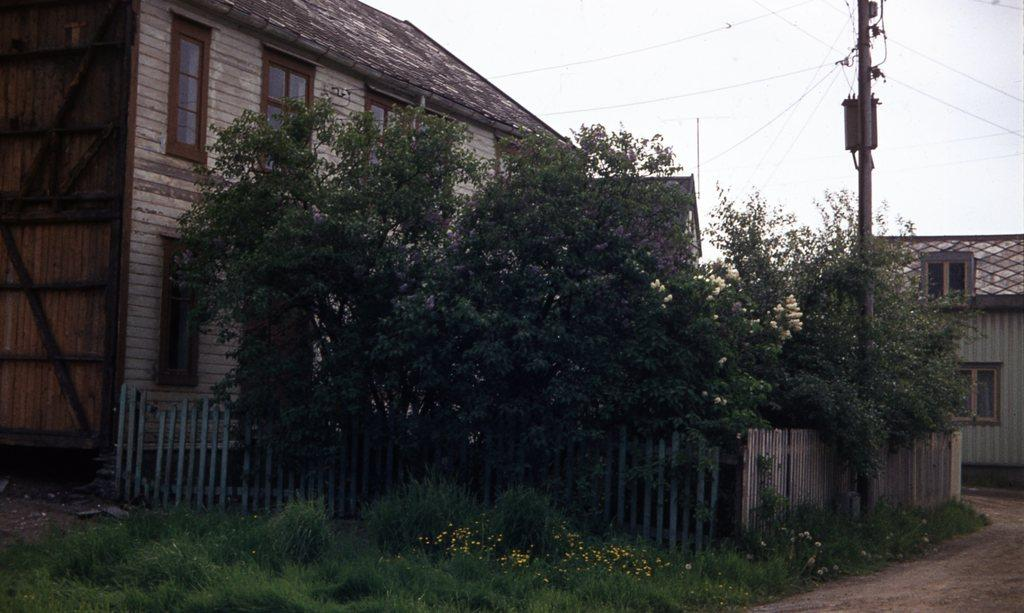What type of structures can be seen in the image? There are buildings in the image. What natural elements are present in the image? There are trees in the image. What type of barrier can be seen in the image? There is a wooden fence in the image. What type of ground cover is visible in the image? There is grass on the ground in the image. What man-made object is present in the image? There is an electrical pole in the image. What is the condition of the sky in the image? The sky is cloudy in the image. Can you see any coal being used in the image? There is no coal present in the image. What type of animal can be seen using its tongue to climb the trees in the image? There are no animals present in the image, let alone one using its tongue to climb trees. 